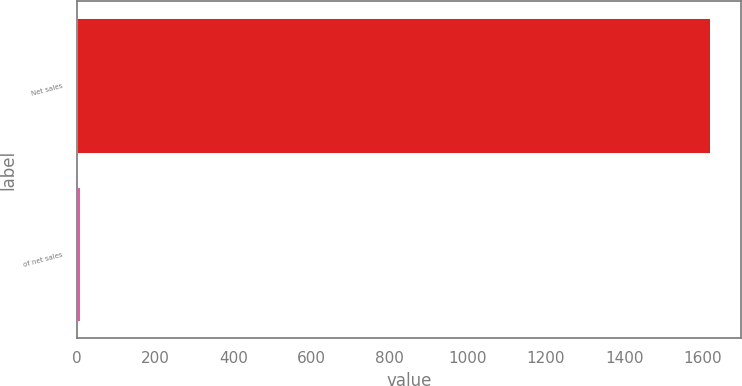Convert chart. <chart><loc_0><loc_0><loc_500><loc_500><bar_chart><fcel>Net sales<fcel>of net sales<nl><fcel>1618.5<fcel>9.2<nl></chart> 